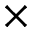<formula> <loc_0><loc_0><loc_500><loc_500>\times</formula> 